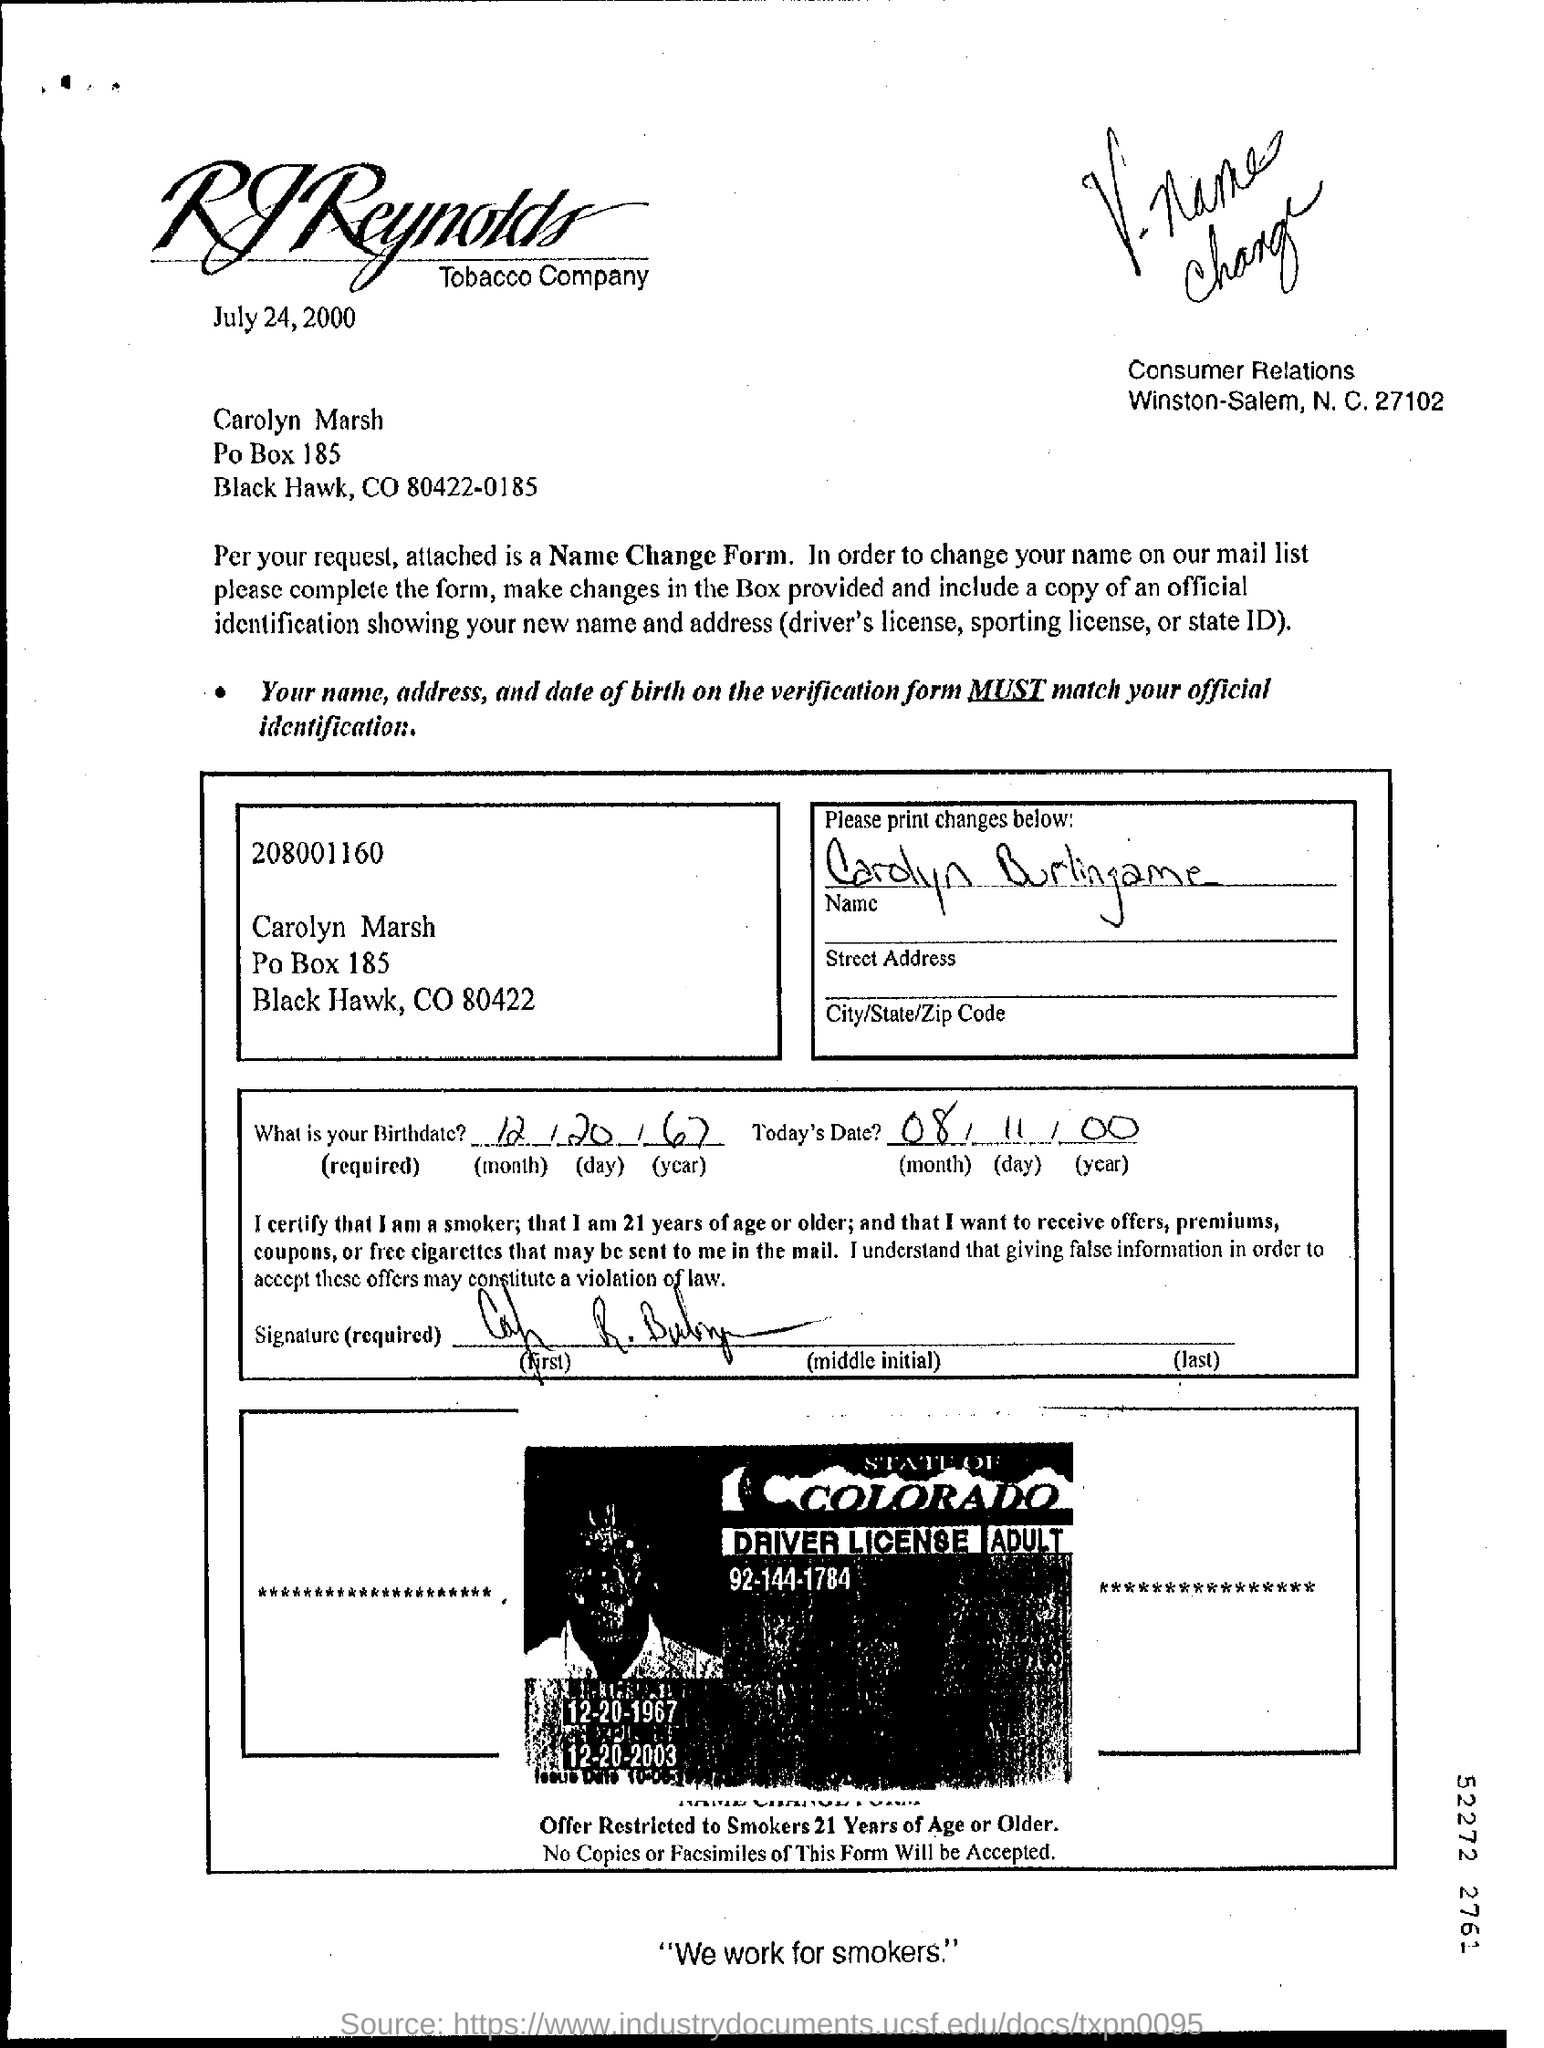Highlight a few significant elements in this photo. The letter is addressed to Carolyn Marsh. The letter is dated July 24, 2000. 